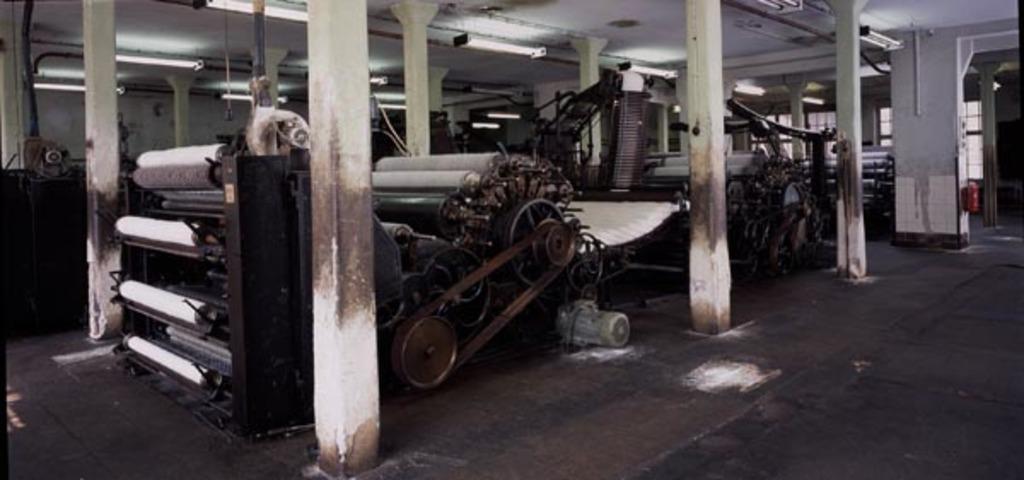In one or two sentences, can you explain what this image depicts? In this image we can see machine, pillars, roof, lights, floor and one red color object. 